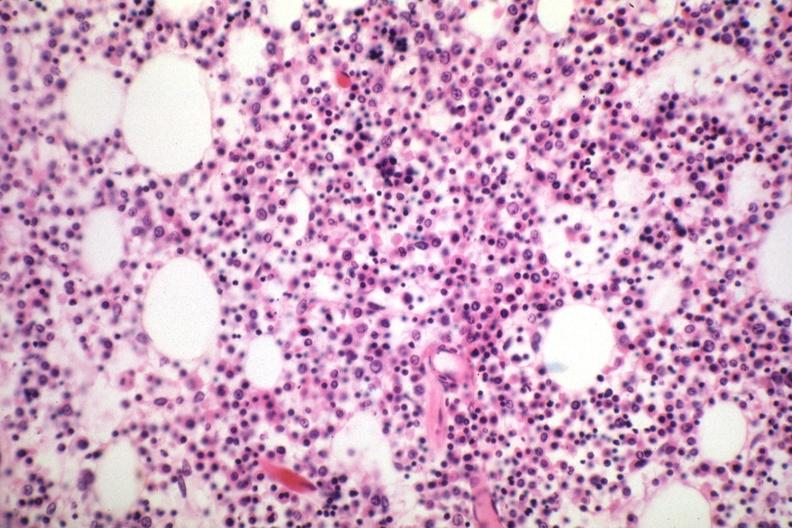s hematologic present?
Answer the question using a single word or phrase. Yes 